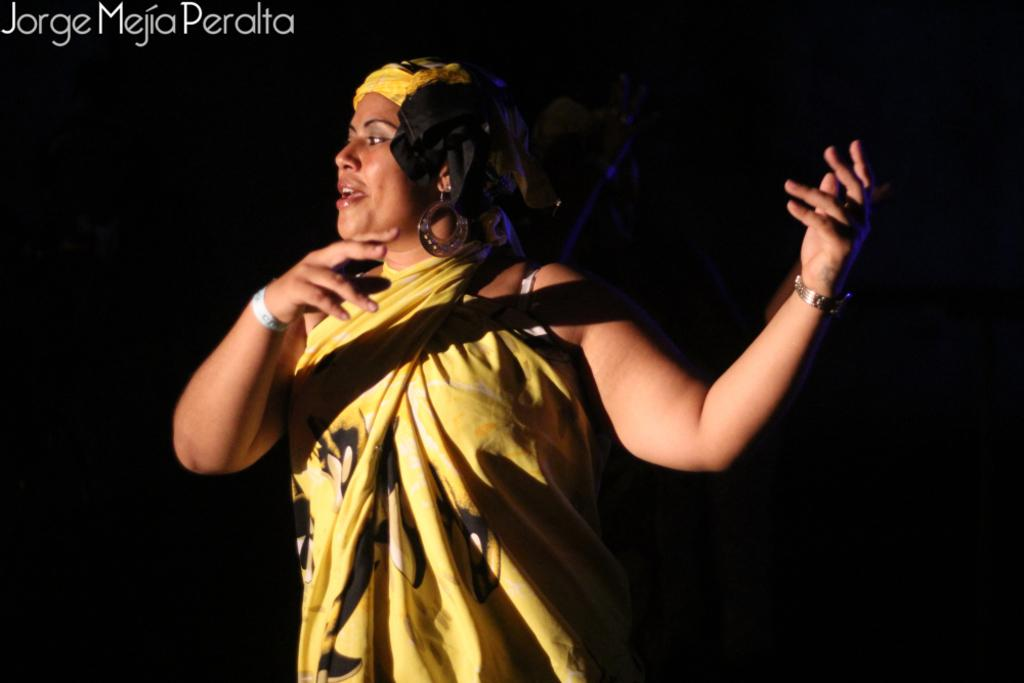Who is present in the image? There is a woman in the image. How many feet are visible in the image? The provided fact does not mention any feet or footwear, so it is impossible to determine the number of feet visible in the image. 